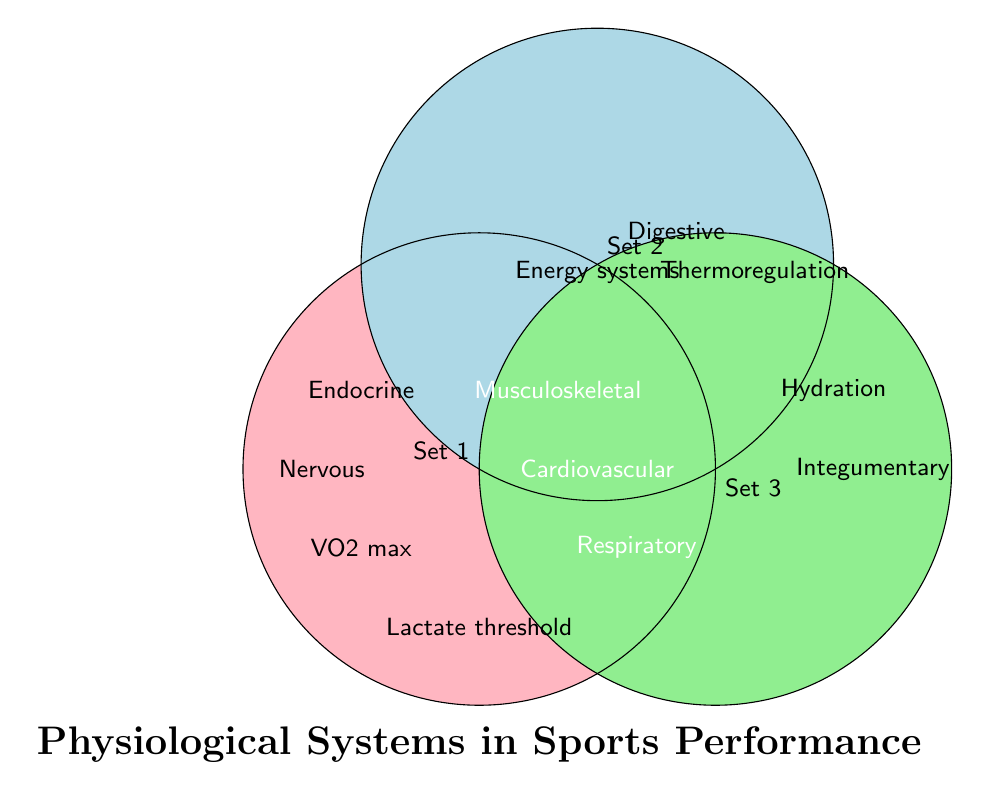What are the names of the three sets in the figure? The three sets are labeled near their respective circles. They are "Set 1", "Set 2", and "Set 3".
Answer: Set 1, Set 2, Set 3 Which physiological systems are present in all three sets? By looking at the center where all three circles overlap, the systems present in the intersection are "Cardiovascular", "Respiratory", and "Musculoskeletal".
Answer: Cardiovascular, Respiratory, Musculoskeletal Which physiological system is unique to only Set 1? The systems specific to only Set 1 are those found in the area of the first circle that does not overlap with others. This includes "VO2 max" and "Lactate threshold".
Answer: VO2 max, Lactate threshold Is there any physiological system that appears in both Set 1 and Set 2 but not in Set 3? The systems that appear in both overlapping areas of Set 1 and Set 2 (but not in Set 3) include "Nervous" and "Endocrine".
Answer: Nervous, Endocrine How many physiological systems are unique to Set 3? The systems present only in Set 3, which are unique, found in the part of the third circle that does not overlap with others, include "Integumentary" and "Hydration".
Answer: Two (Integumentary, Hydration) Which physiological systems are shared between Set 2 and Set 3 but not in Set 1? The systems in the overlapping area between Set 2 and Set 3 but excluding Set 1 include "Digestive".
Answer: Digestive Compare the number of physiological systems present in only one set to those present in more than one set. Count the systems in only one set (VO2 max, Lactate threshold, Integumentary, Hydration) gives 4. For systems in more than one set, count the remainder. There are "Nervous", "Endocrine" (2) in two sets, and three systems (Cardiovascular, Respiratory, Musculoskeletal) in all three sets, total 5.
Answer: 4 vs 5 Which set contains "Thermoregulation"? Find the label "Thermoregulation" which is within Set 2 and Set 3 area.
Answer: Set 2 and Set 3 